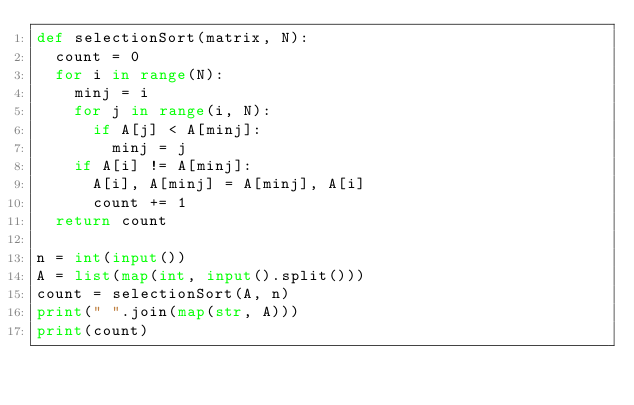<code> <loc_0><loc_0><loc_500><loc_500><_Python_>def selectionSort(matrix, N):
  count = 0
  for i in range(N):
    minj = i
    for j in range(i, N):
      if A[j] < A[minj]:
        minj = j
    if A[i] != A[minj]:
      A[i], A[minj] = A[minj], A[i]
      count += 1
  return count

n = int(input())
A = list(map(int, input().split()))
count = selectionSort(A, n)
print(" ".join(map(str, A)))
print(count)

</code> 